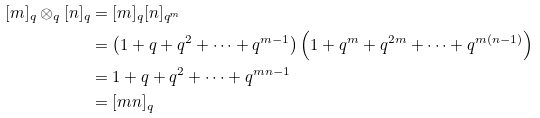<formula> <loc_0><loc_0><loc_500><loc_500>[ m ] _ { q } \otimes _ { q } [ n ] _ { q } & = [ m ] _ { q } [ n ] _ { q ^ { m } } \\ & = \left ( 1 + q + q ^ { 2 } + \cdots + q ^ { m - 1 } \right ) \left ( 1 + q ^ { m } + q ^ { 2 m } + \cdots + q ^ { m ( n - 1 ) } \right ) \\ & = 1 + q + q ^ { 2 } + \cdots + q ^ { m n - 1 } \\ & = [ m n ] _ { q }</formula> 